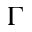<formula> <loc_0><loc_0><loc_500><loc_500>\Gamma</formula> 